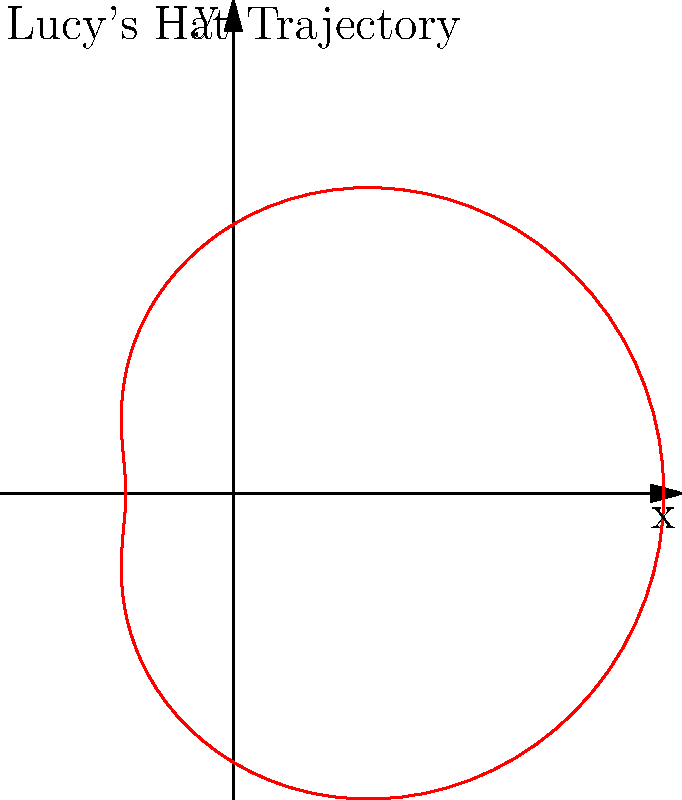In the iconic opening credits of "I Love Lucy," Lucy tosses her hat in a playful arc. If we model the trajectory of her hat using the polar equation $r = 5 + 3\cos(\theta)$, what is the maximum distance the hat reaches from the origin? To find the maximum distance the hat reaches from the origin, we need to follow these steps:

1) The given polar equation is $r = 5 + 3\cos(\theta)$.

2) The maximum distance will occur when $\cos(\theta)$ is at its maximum value, which is 1.

3) When $\cos(\theta) = 1$, the equation becomes:

   $r_{max} = 5 + 3(1) = 5 + 3 = 8$

4) Therefore, the maximum distance the hat reaches from the origin is 8 units.

This corresponds to the top of the heart-shaped curve in the polar plot, which represents the highest point in Lucy's hat toss.
Answer: 8 units 